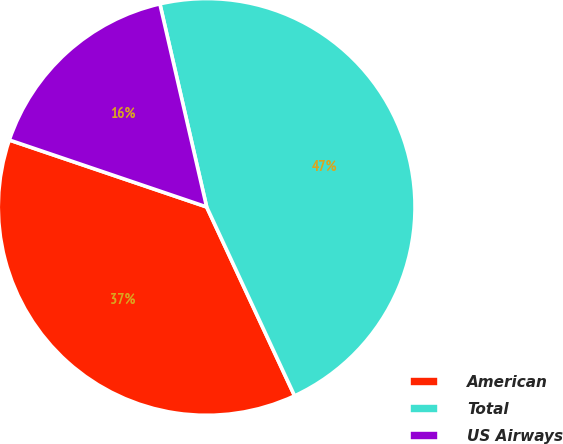<chart> <loc_0><loc_0><loc_500><loc_500><pie_chart><fcel>American<fcel>Total<fcel>US Airways<nl><fcel>37.14%<fcel>46.67%<fcel>16.19%<nl></chart> 